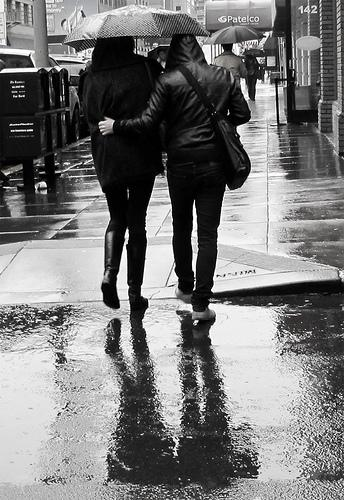Question: what color film has been used?
Choices:
A. Blue.
B. Red.
C. Black and white.
D. Purple.
Answer with the letter. Answer: C Question: how many people are in front of the camera?
Choices:
A. 1.
B. 6.
C. 5.
D. 2.
Answer with the letter. Answer: D Question: what are they holding above their heads?
Choices:
A. Paper.
B. An umbrella.
C. Signs.
D. Brief case.
Answer with the letter. Answer: B Question: who is wearing a messenger bag?
Choices:
A. The man on the left.
B. The woman in front.
C. The lady in the back.
D. The man on the right.
Answer with the letter. Answer: D Question: why are they holding umbrellas?
Choices:
A. It is storming.
B. Bad weather.
C. It is raining.
D. Storm warnings.
Answer with the letter. Answer: C Question: where is his arm?
Choices:
A. In the air.
B. By his side.
C. Around her waist.
D. Holding her hand.
Answer with the letter. Answer: C 